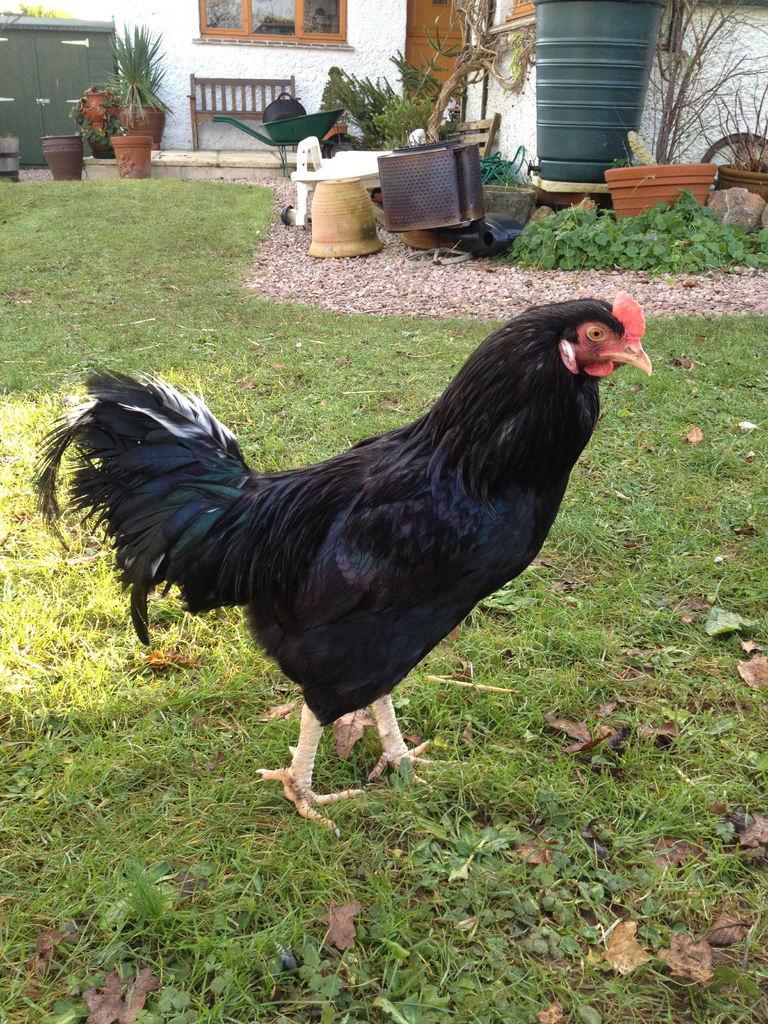Describe this image in one or two sentences. In this image I can see a black color hen on the ground. In the background there are some flower pots, a bench, drum and other objects are placed and also there is a wall along with the window and door. 